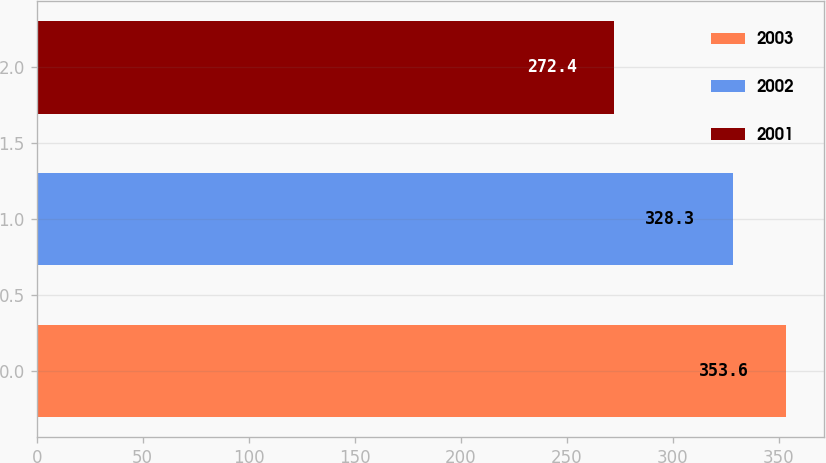<chart> <loc_0><loc_0><loc_500><loc_500><bar_chart><fcel>2003<fcel>2002<fcel>2001<nl><fcel>353.6<fcel>328.3<fcel>272.4<nl></chart> 